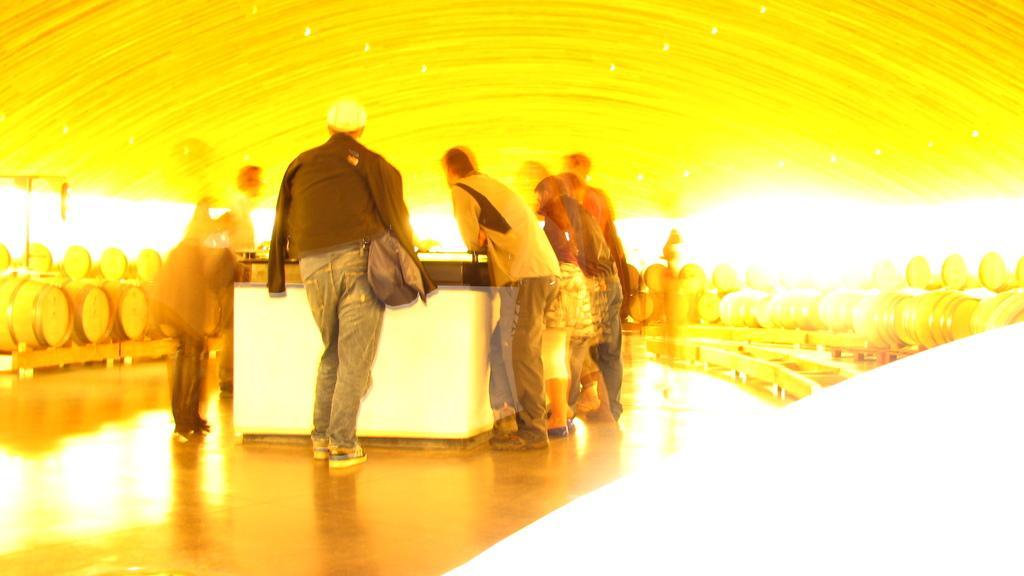In one or two sentences, can you explain what this image depicts? In this image I can see few people are standing in front of the table. One person is wearing bag. I can see few objects around. I can see a yellow and white shade. 